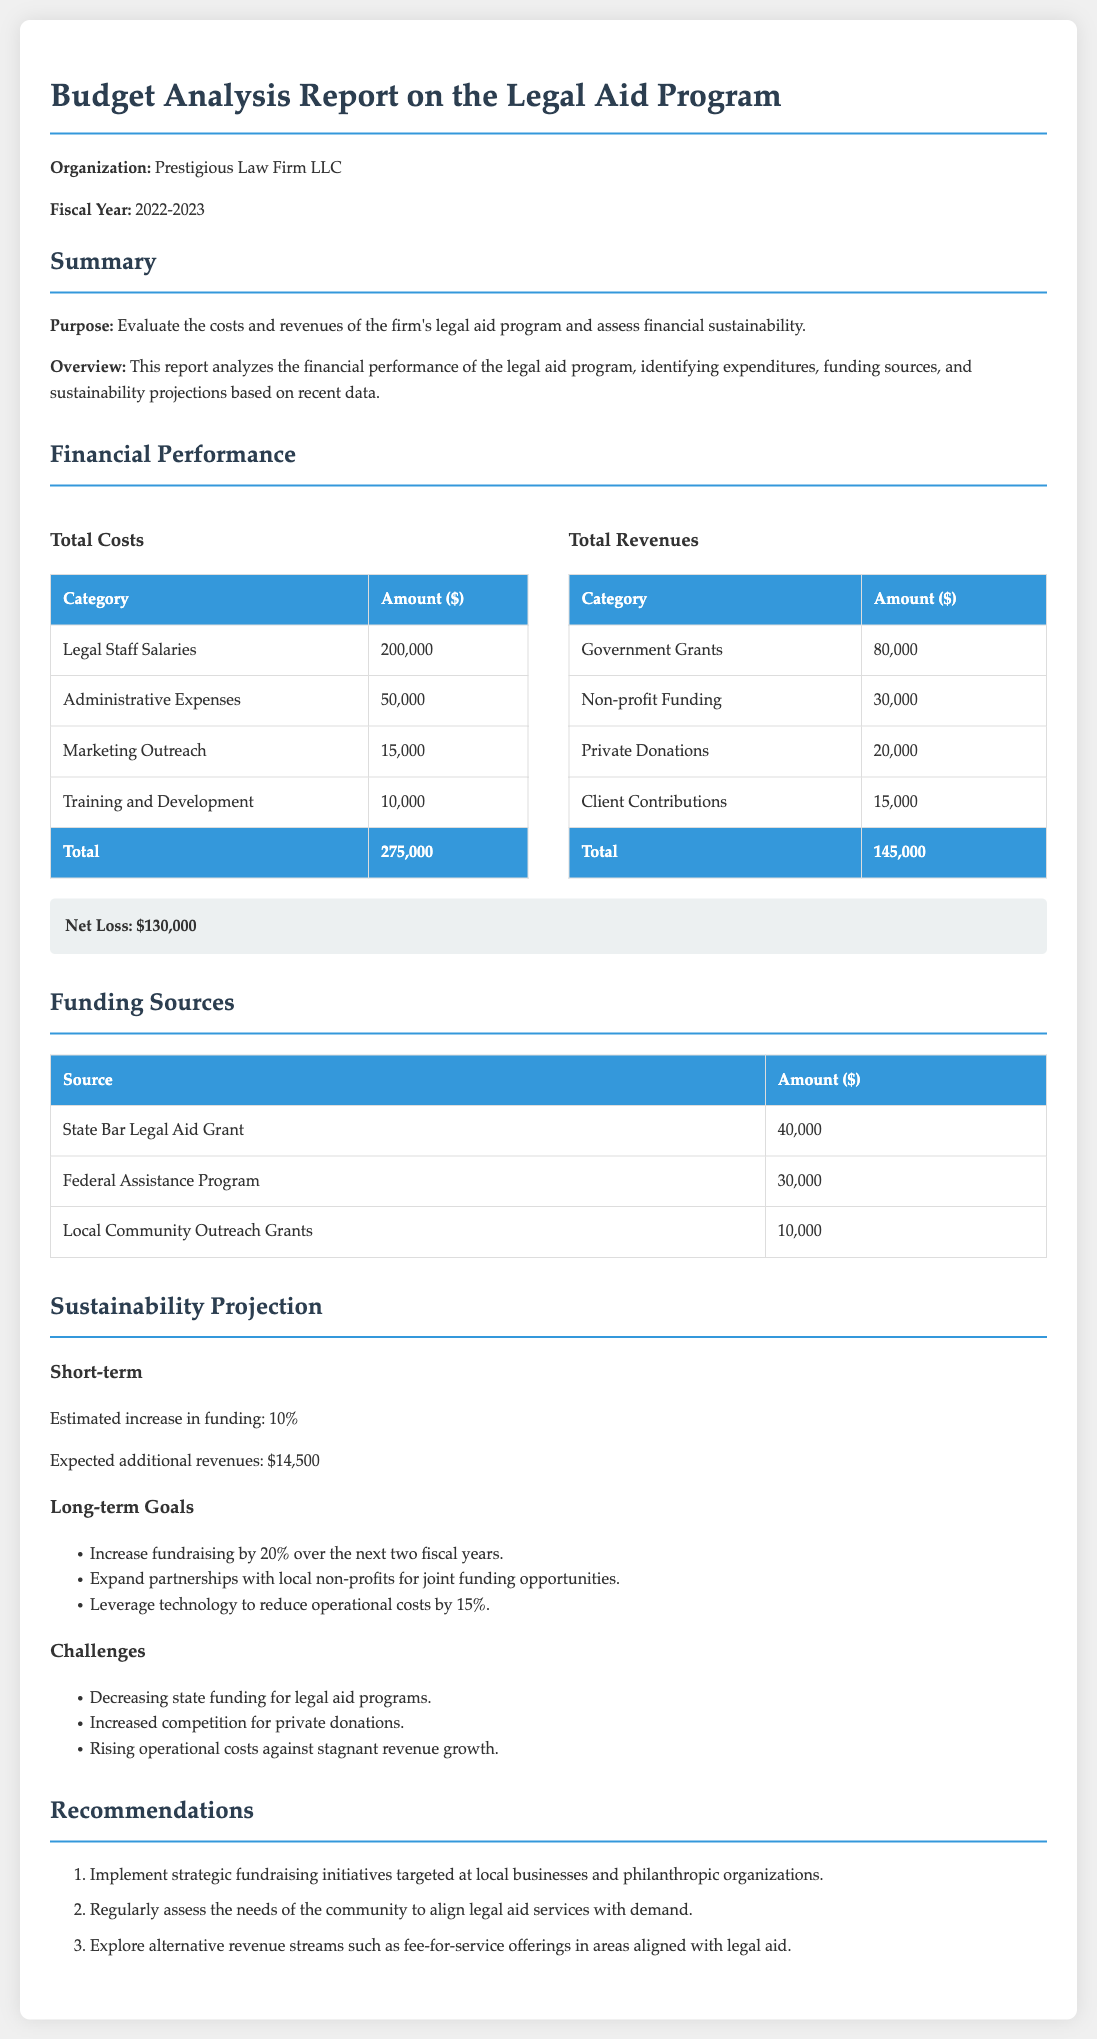What is the total cost of legal staff salaries? The total cost of legal staff salaries is stated directly in the financial performance section of the document.
Answer: 200,000 What is the net loss of the legal aid program? The net loss is highlighted in the financial performance section and is calculated as total costs minus total revenues.
Answer: $130,000 What is the amount of private donations? The amount of private donations is specifically listed in the total revenues table under revenues.
Answer: 20,000 What is the estimated increase in funding for the short-term? The estimated increase in funding is provided in the sustainability projection section as a percentage.
Answer: 10% Which funding source contributes $40,000? The specific source of this funding is noted in the funding sources table within the document.
Answer: State Bar Legal Aid Grant What percentage of fundraising increase is targeted for long-term goals? The targeted percentage for fundraising increase over the next two fiscal years is mentioned in the long-term goals section.
Answer: 20% What are the rising costs mentioned as a challenge? The document lists challenges faced by the legal aid program in the sustainability projection section.
Answer: Rising operational costs What is one recommendation for enhancing funding? The recommendations section contains strategic initiatives aimed at improving financial sustainability.
Answer: Implement strategic fundraising initiatives 